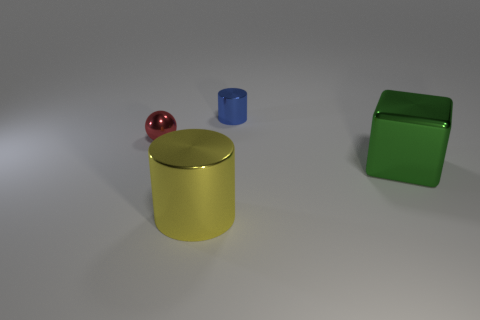The shiny ball is what color?
Provide a short and direct response. Red. What is the material of the cylinder that is behind the green thing?
Offer a terse response. Metal. Is the number of large green metal things that are on the right side of the yellow shiny object the same as the number of big green shiny cubes?
Your answer should be compact. Yes. Is the green shiny object the same shape as the blue metal object?
Your answer should be compact. No. Is there anything else that has the same color as the metal cube?
Give a very brief answer. No. What is the shape of the shiny thing that is both right of the big yellow thing and in front of the red shiny object?
Your answer should be very brief. Cube. Are there an equal number of big metal objects behind the green cube and small red objects that are behind the tiny red object?
Offer a terse response. Yes. How many cylinders are either blue shiny objects or tiny green things?
Your answer should be compact. 1. How many big green objects have the same material as the red object?
Give a very brief answer. 1. What is the object that is both behind the green block and left of the tiny blue cylinder made of?
Make the answer very short. Metal. 